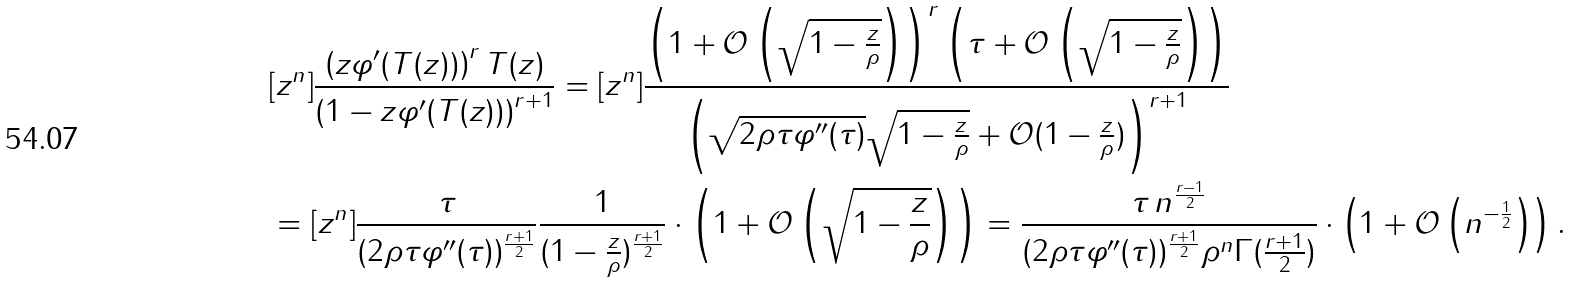<formula> <loc_0><loc_0><loc_500><loc_500>& [ z ^ { n } ] \frac { \left ( z \varphi ^ { \prime } ( T ( z ) ) \right ) ^ { r } T ( z ) } { \left ( 1 - z \varphi ^ { \prime } ( T ( z ) ) \right ) ^ { r + 1 } } = [ z ^ { n } ] \frac { \left ( 1 + \mathcal { O } \left ( \sqrt { 1 - \frac { z } { \rho } } \right ) \right ) ^ { r } \left ( \tau + \mathcal { O } \left ( \sqrt { 1 - \frac { z } { \rho } } \right ) \right ) } { \left ( \sqrt { 2 \rho \tau \varphi ^ { \prime \prime } ( \tau ) } \sqrt { 1 - \frac { z } { \rho } } + \mathcal { O } ( 1 - \frac { z } { \rho } ) \right ) ^ { r + 1 } } \\ & = [ z ^ { n } ] \frac { \tau } { ( 2 \rho \tau \varphi ^ { \prime \prime } ( \tau ) ) ^ { \frac { r + 1 } { 2 } } } \frac { 1 } { ( 1 - \frac { z } { \rho } ) ^ { \frac { r + 1 } { 2 } } } \cdot \left ( 1 + \mathcal { O } \left ( \sqrt { 1 - \frac { z } { \rho } } \right ) \right ) = \frac { \tau \, n ^ { \frac { r - 1 } { 2 } } } { ( 2 \rho \tau \varphi ^ { \prime \prime } ( \tau ) ) ^ { \frac { r + 1 } { 2 } } \rho ^ { n } \Gamma ( \frac { r + 1 } { 2 } ) } \cdot \left ( 1 + \mathcal { O } \left ( n ^ { - \frac { 1 } { 2 } } \right ) \right ) .</formula> 